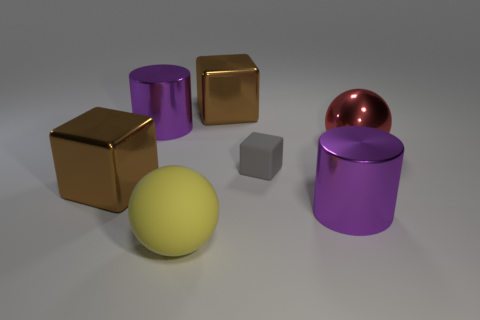Subtract all brown cubes. How many cubes are left? 1 Add 1 large cyan cylinders. How many objects exist? 8 Subtract all gray blocks. How many blocks are left? 2 Subtract all cyan cylinders. How many brown blocks are left? 2 Subtract all blocks. How many objects are left? 4 Subtract all brown balls. Subtract all cyan cubes. How many balls are left? 2 Subtract all tiny yellow spheres. Subtract all red shiny spheres. How many objects are left? 6 Add 4 gray blocks. How many gray blocks are left? 5 Add 6 blue objects. How many blue objects exist? 6 Subtract 1 gray cubes. How many objects are left? 6 